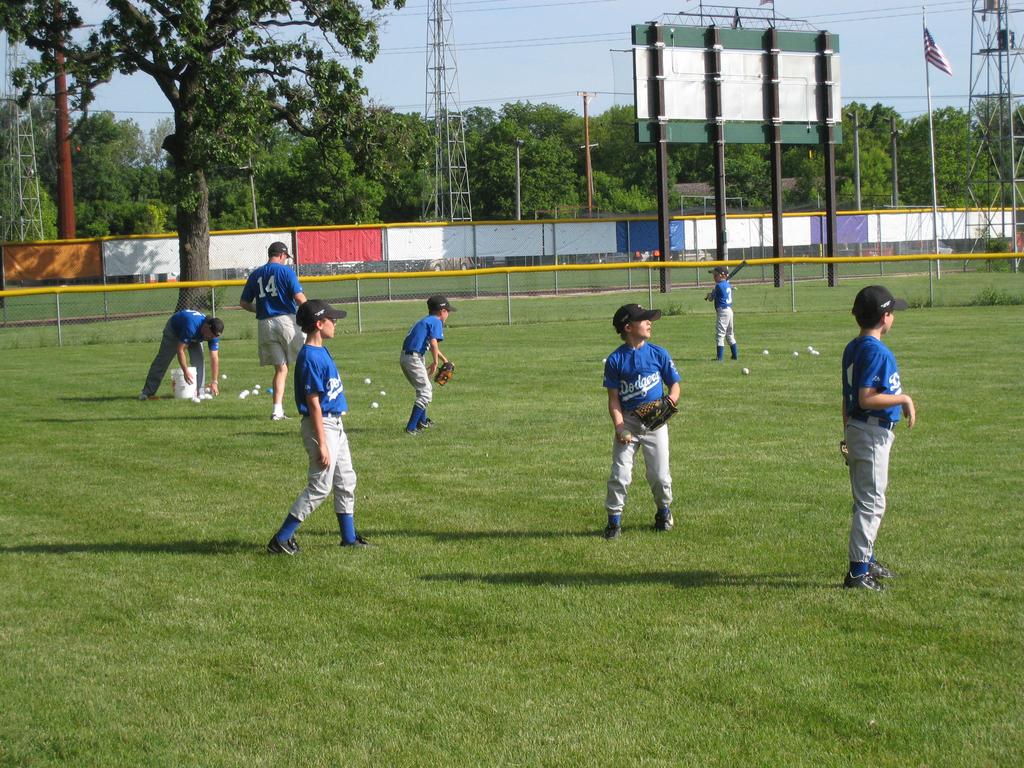What is the name of this team?
Your answer should be compact. Dodgers. 